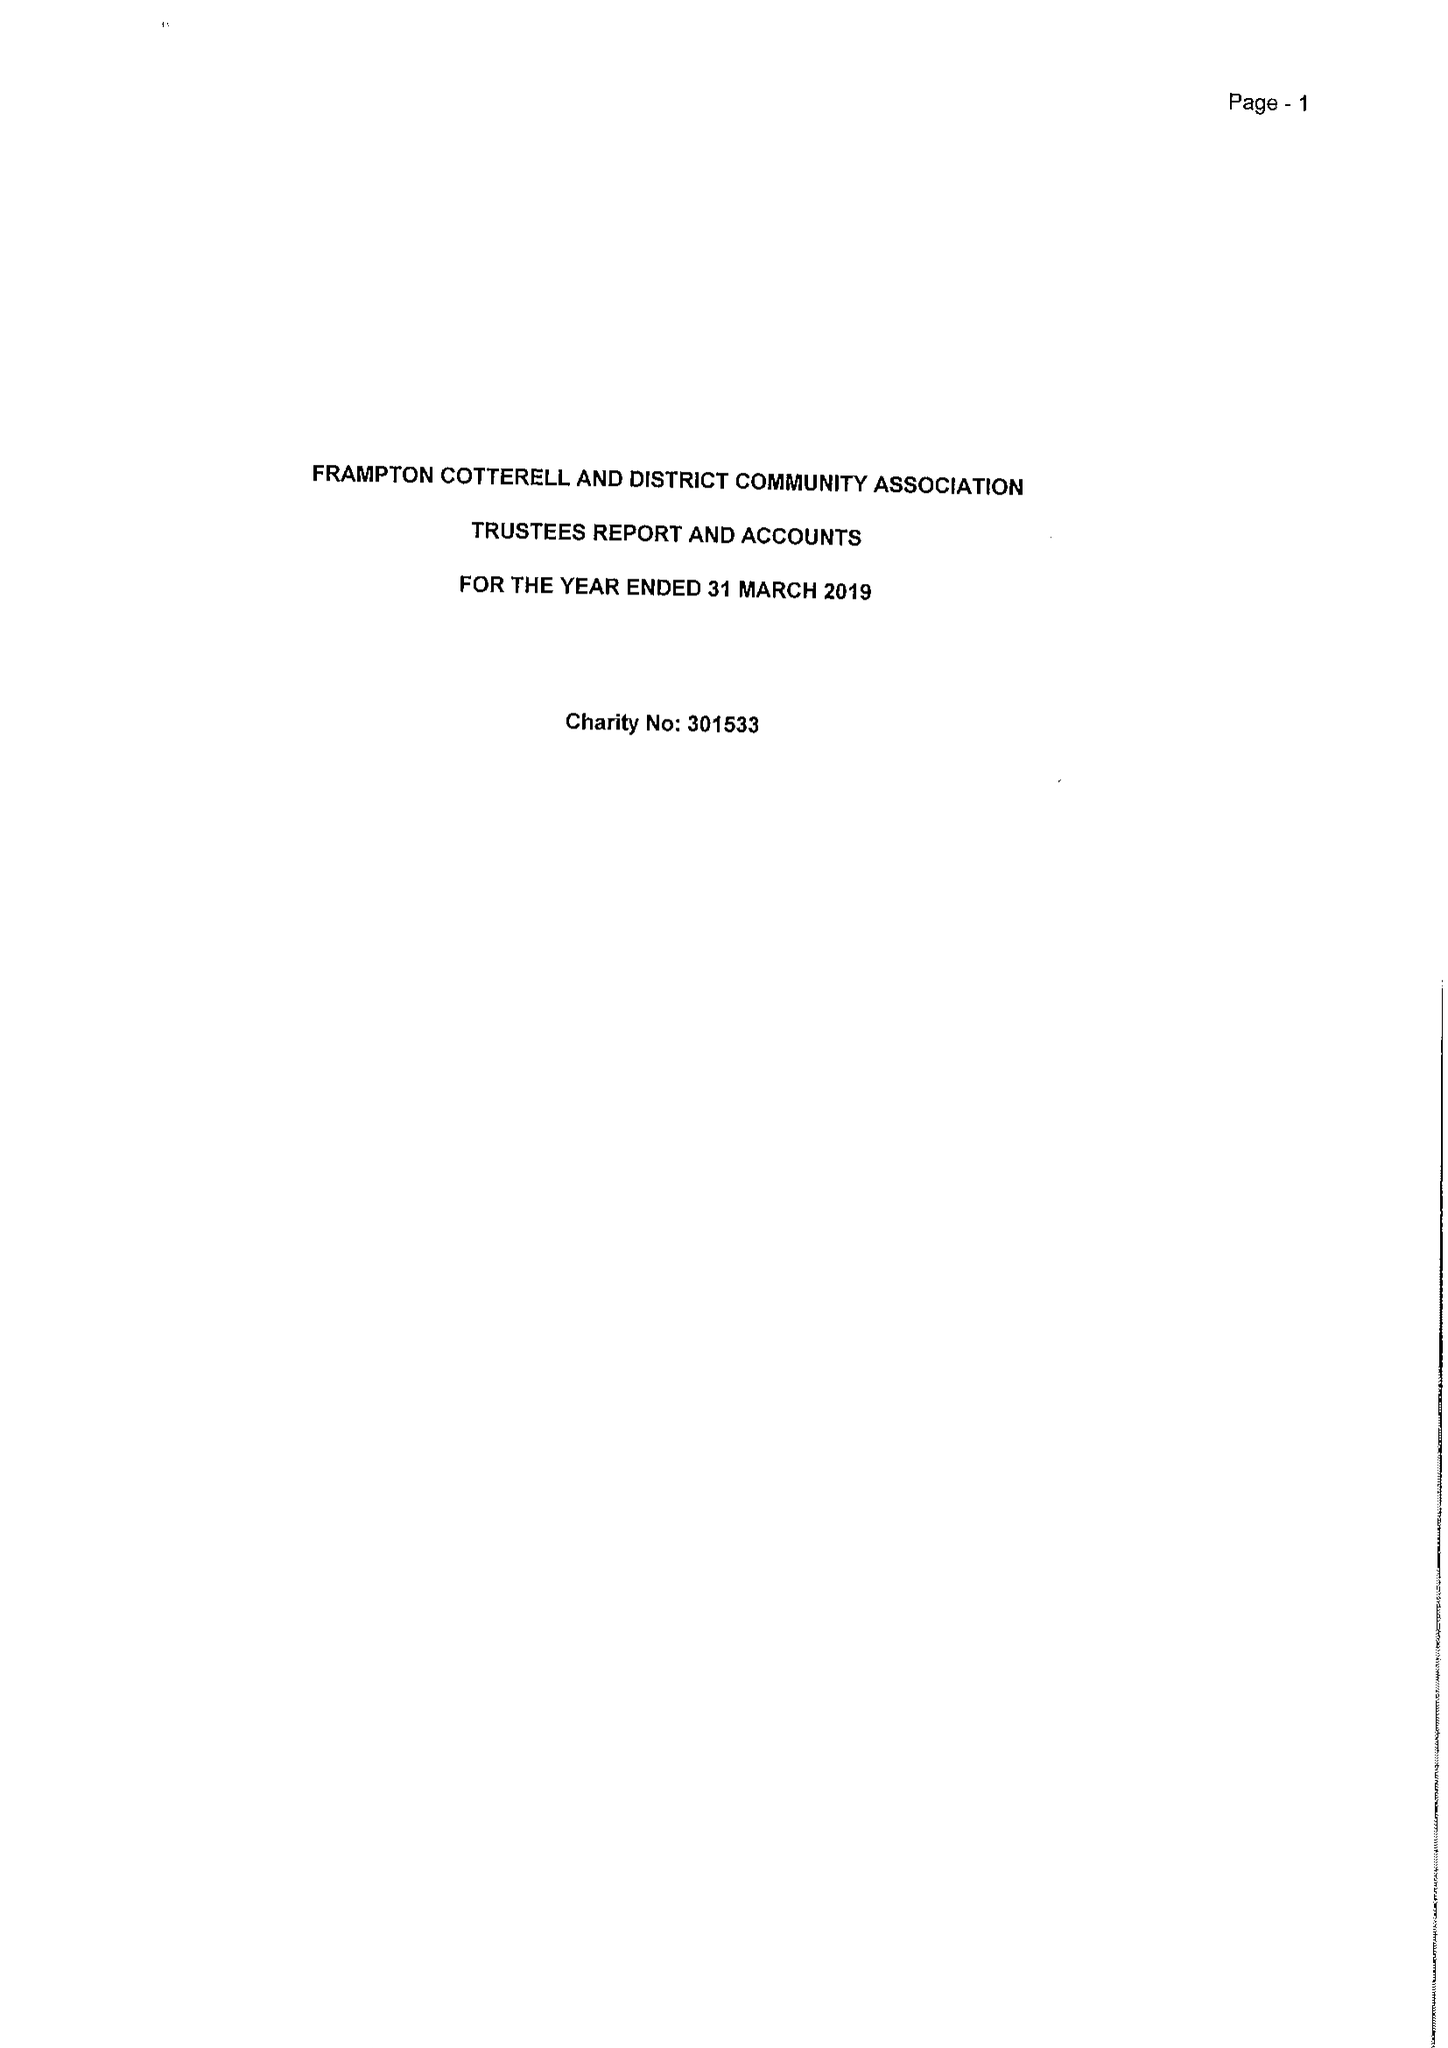What is the value for the address__street_line?
Answer the question using a single word or phrase. 35 SCHOOL ROAD 